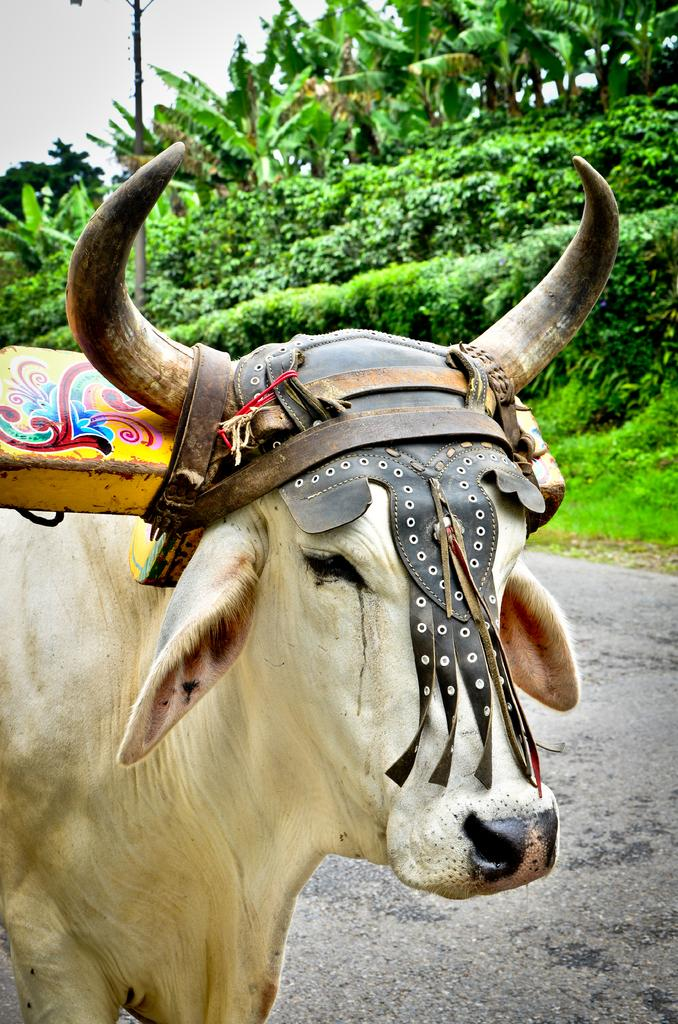What animal can be seen in the image? There is a cow in the image. Where is the cow located in the image? The cow is standing on the road. What is attached to the cow's neck? There is a wooden rod on the cow's neck. What type of vegetation is visible beside the road? There are trees and plants beside the road. What type of swing can be seen hanging from the trees beside the road? There is no swing present in the image; only the cow, the wooden rod, and the vegetation are visible. 